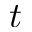<formula> <loc_0><loc_0><loc_500><loc_500>t</formula> 